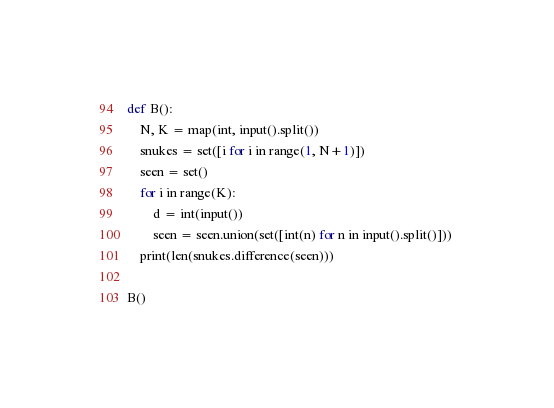<code> <loc_0><loc_0><loc_500><loc_500><_Python_>def B():
    N, K = map(int, input().split())
    snukes = set([i for i in range(1, N+1)])
    seen = set()
    for i in range(K):
        d = int(input())
        seen = seen.union(set([int(n) for n in input().split()])) 
    print(len(snukes.difference(seen)))
        
B()</code> 